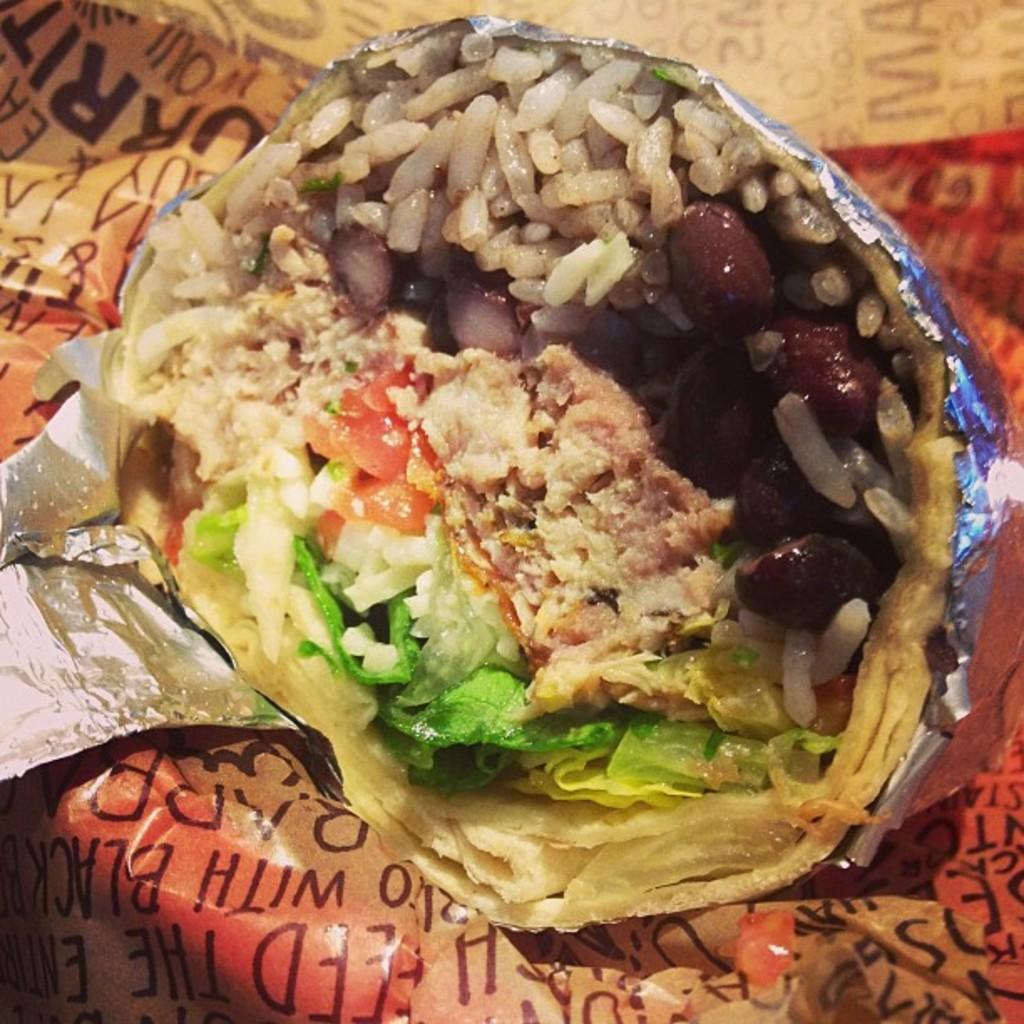What can be seen in the image related to food? There is food in the image. Can you describe the covers with text in the image? There are covers with text in the image. How do the snails contribute to the expansion of the food in the image? There are no snails present in the image, so they cannot contribute to the expansion of the food. 